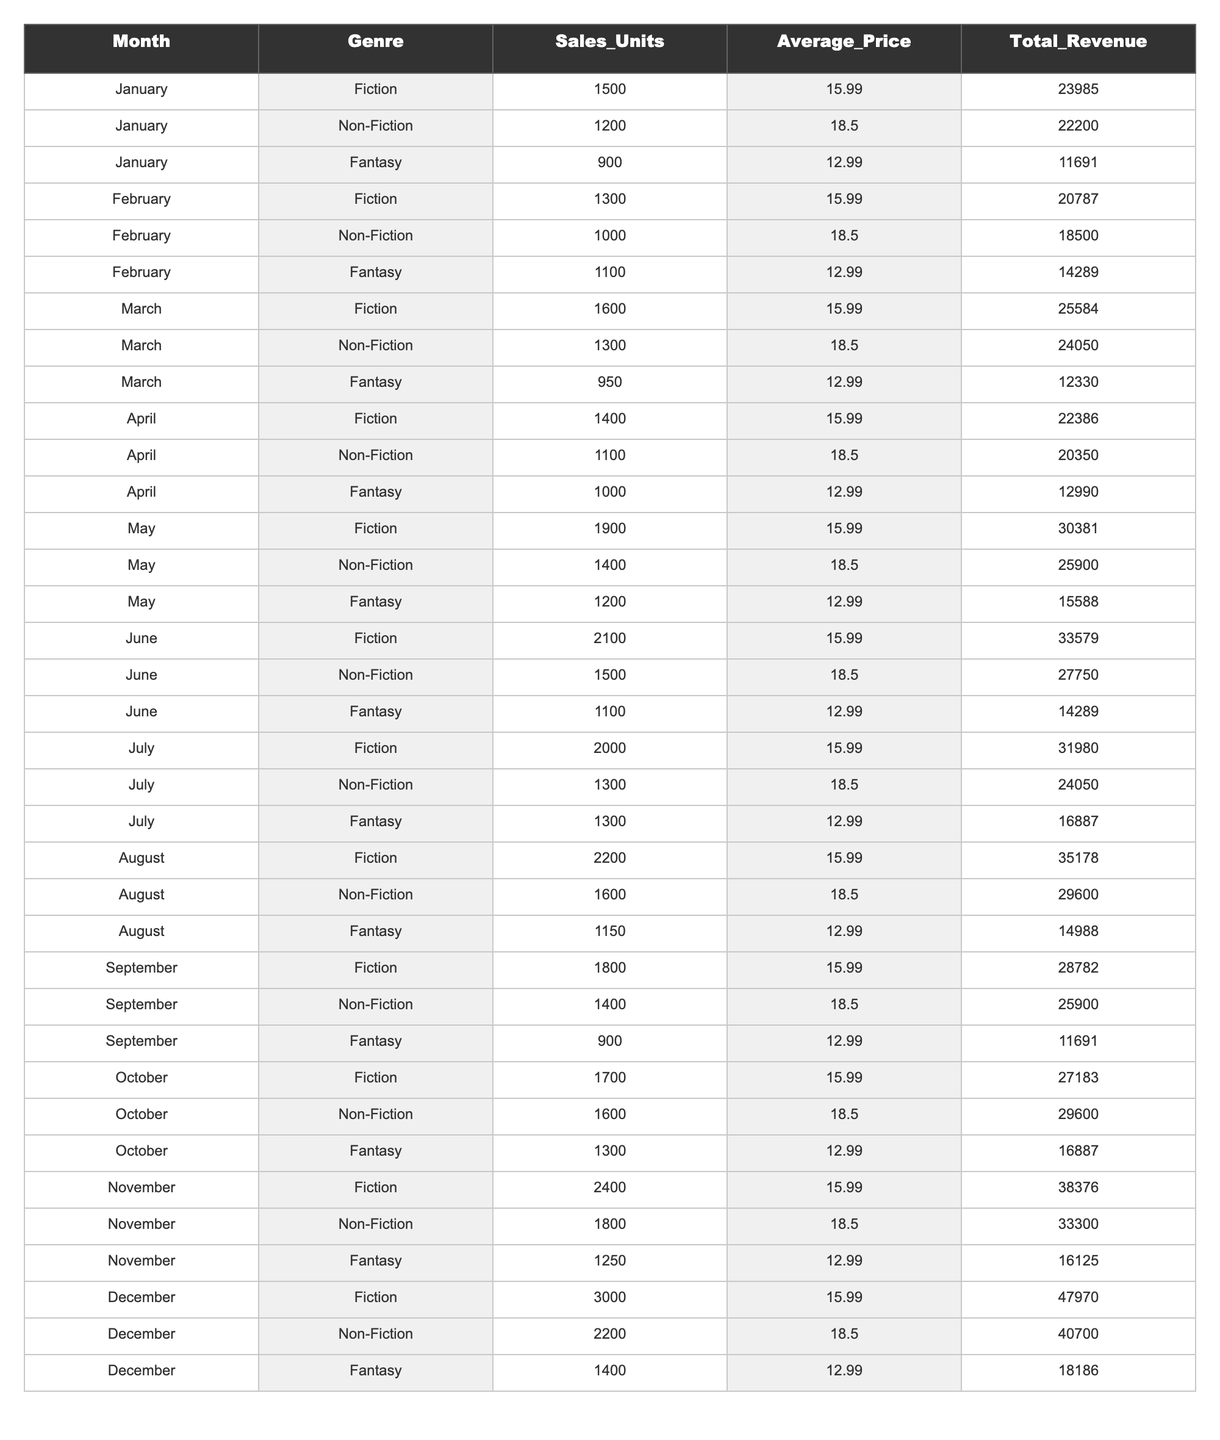What is the total revenue generated from Fiction sales in December? For December, the revenue for Fiction is listed as 47970. Thus, the total revenue from Fiction sales in December is directly found in the table.
Answer: 47970 Which genre had the highest sales units in November? In November, the table shows that Fiction had 2400 sales units, Non-Fiction had 1800, and Fantasy had 1250. Therefore, Fiction had the highest sales units.
Answer: Fiction What is the difference in total revenue between Non-Fiction and Fantasy in June? In June, Non-Fiction generated a total revenue of 27750 and Fantasy generated 14289. The difference is calculated as 27750 - 14289 = 13461.
Answer: 13461 What was the average sales units per genre in January? In January, the total sales units for all three genres (Fiction, Non-Fiction, Fantasy) are 1500 + 1200 + 900 = 3900. Since there are three genres, the average is 3900 / 3 = 1300.
Answer: 1300 In which month did Fantasy genre have the lowest sales units? The table shows that Fantasy's lowest sales unit occurred in January with 900 units. Looking at the other months, none had a lower sales figures than this.
Answer: January What is the total revenue for all genres combined in May? For May, the total revenue is calculated as follows: Fiction (30381) + Non-Fiction (25900) + Fantasy (15588) = 71869. This total is derived from adding up the revenues from each genre.
Answer: 71869 Was the average price of Non-Fiction books higher than both Fiction and Fantasy in April? In April, Non-Fiction had an average price of 18.50, Fiction had 15.99, and Fantasy had 12.99. Comparing the figures, Non-Fiction's average price is higher than both of the others.
Answer: Yes Which month had the highest sales units for Non-Fiction? By examining the table, July had the highest sales units for Non-Fiction with 1300 sales units, higher than any other month listed.
Answer: July What is the overall trend in sales units for Fiction from January to December? Analyzing the sales units: January (1500), February (1300), March (1600), April (1400), May (1900), June (2100), July (2000), August (2200), September (1800), October (1700), November (2400), December (3000). The trend shows an initial fluctuation but ends at a peak in December showing growth over the year, overall showcasing an upward trend.
Answer: Upward Which genre consistently had the lowest sales units throughout the year? Reviewing each month, Fantasy consistently had lower sales units relative to Fiction and Non-Fiction as it never exceeded 1300 sales units.
Answer: Fantasy 